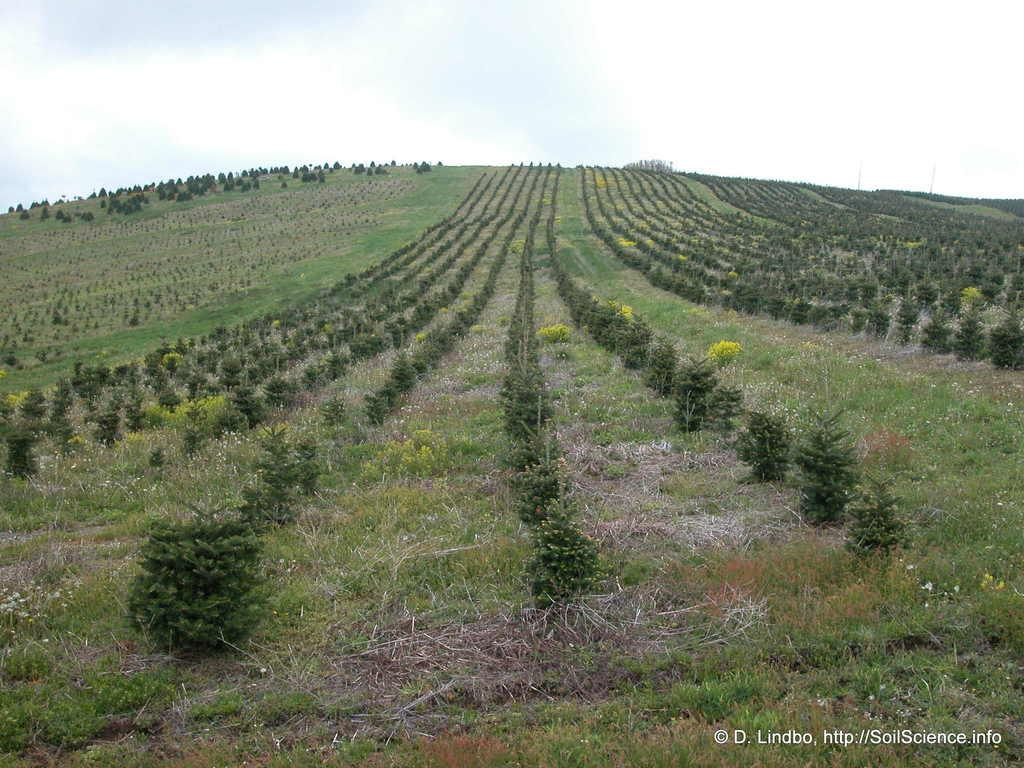What type of vegetation can be seen in the image? There is grass and plants in the image. What can be seen in the background of the image? The sky is visible in the background of the image. Is there any text or marking in the image? Yes, there is a watermark in the bottom right corner of the image. What type of chalk is being used to draw on the notebook in the image? There is no chalk or notebook present in the image; it only features grass, plants, and a sky background. 